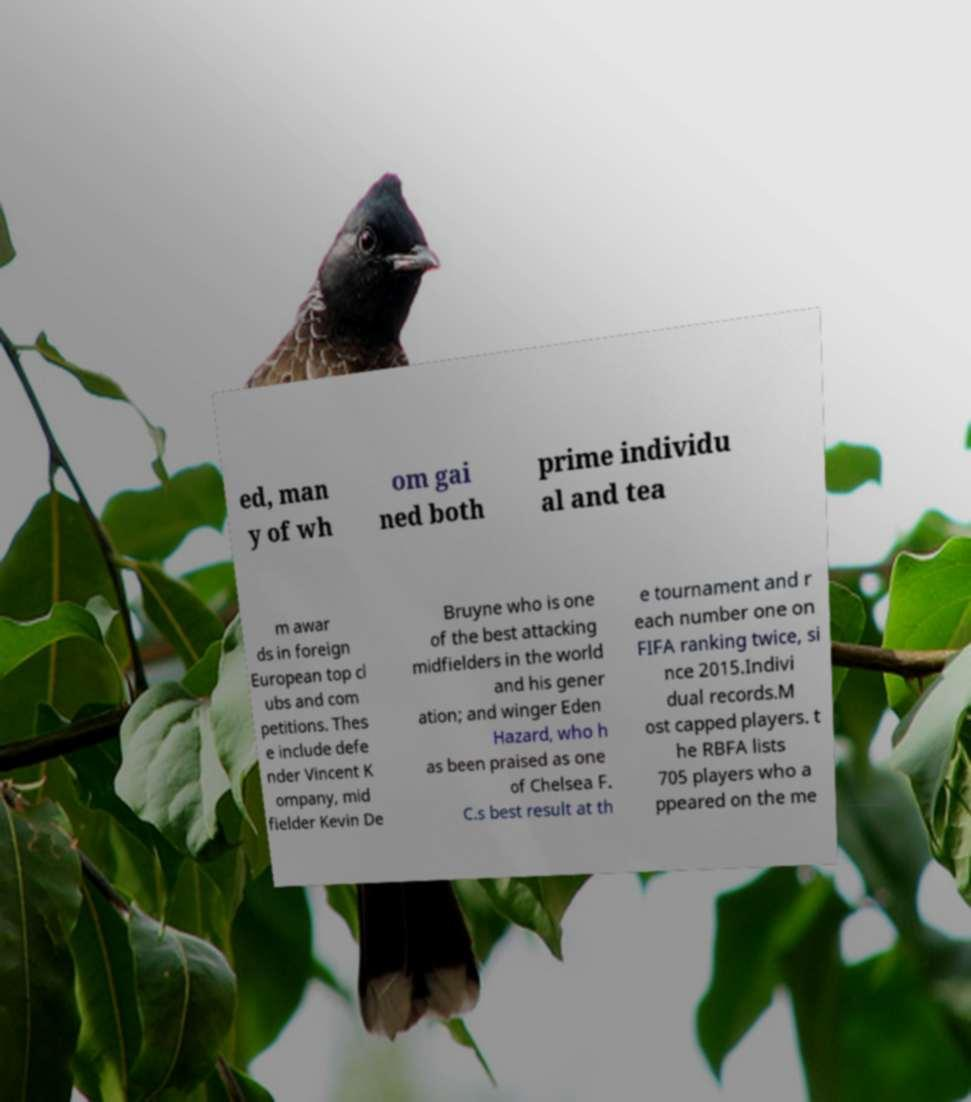For documentation purposes, I need the text within this image transcribed. Could you provide that? ed, man y of wh om gai ned both prime individu al and tea m awar ds in foreign European top cl ubs and com petitions. Thes e include defe nder Vincent K ompany, mid fielder Kevin De Bruyne who is one of the best attacking midfielders in the world and his gener ation; and winger Eden Hazard, who h as been praised as one of Chelsea F. C.s best result at th e tournament and r each number one on FIFA ranking twice, si nce 2015.Indivi dual records.M ost capped players. t he RBFA lists 705 players who a ppeared on the me 